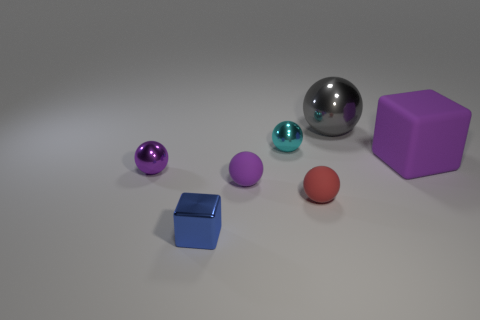Are there any big cubes that have the same color as the large metallic sphere?
Ensure brevity in your answer.  No. The cyan shiny ball is what size?
Provide a succinct answer. Small. Do the tiny shiny cube and the big block have the same color?
Provide a short and direct response. No. How many things are blocks or purple balls that are to the left of the tiny metal block?
Give a very brief answer. 3. How many small rubber things are in front of the purple ball to the right of the cube in front of the large purple matte block?
Your answer should be compact. 1. What number of purple metallic cubes are there?
Make the answer very short. 0. Do the purple rubber object on the right side of the gray ball and the blue object have the same size?
Offer a very short reply. No. How many matte objects are tiny cylinders or tiny cyan balls?
Your answer should be compact. 0. How many small purple objects are on the left side of the purple sphere right of the tiny cube?
Provide a succinct answer. 1. What shape is the purple object that is left of the large gray object and on the right side of the blue shiny thing?
Your answer should be compact. Sphere. 